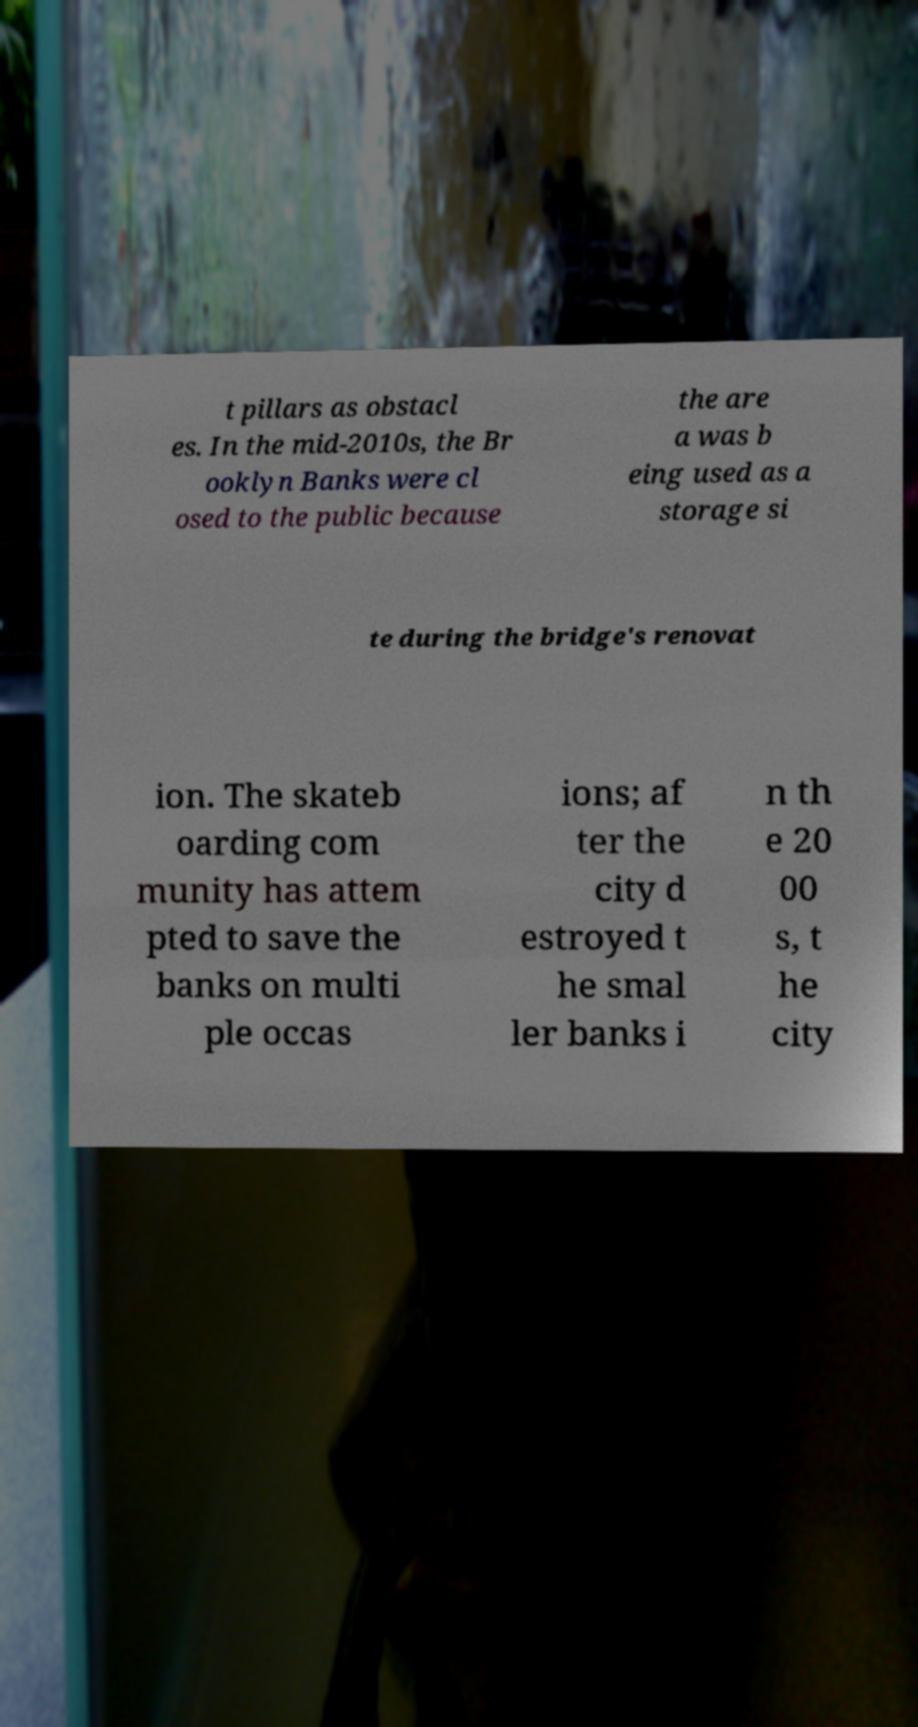I need the written content from this picture converted into text. Can you do that? t pillars as obstacl es. In the mid-2010s, the Br ooklyn Banks were cl osed to the public because the are a was b eing used as a storage si te during the bridge's renovat ion. The skateb oarding com munity has attem pted to save the banks on multi ple occas ions; af ter the city d estroyed t he smal ler banks i n th e 20 00 s, t he city 